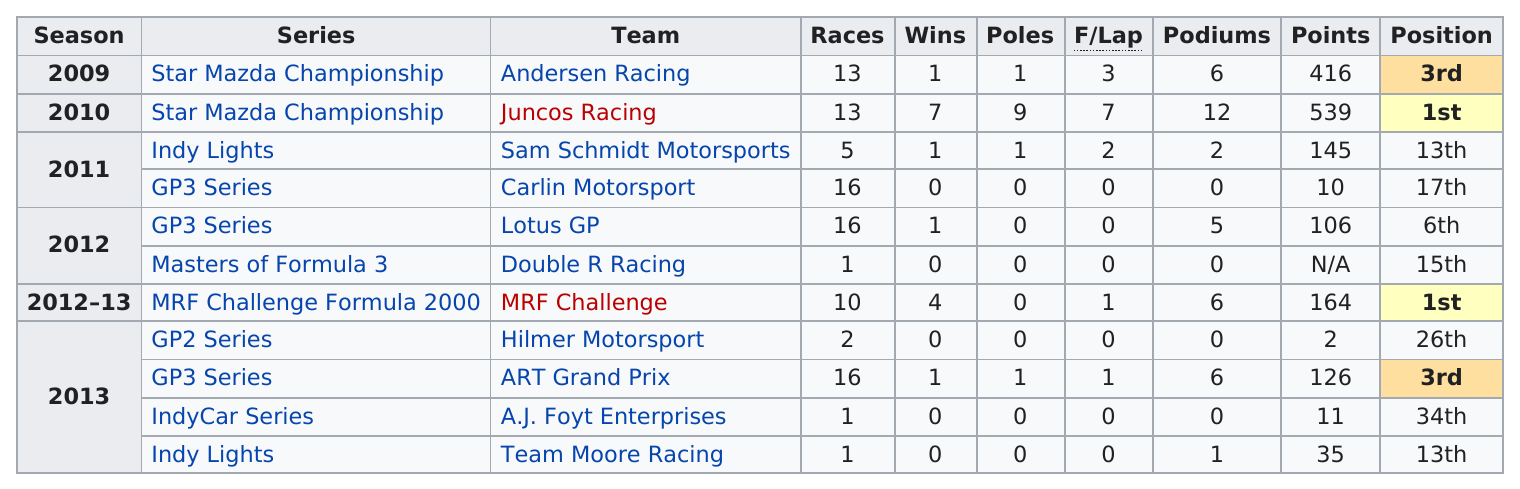Outline some significant characteristics in this image. In the 2010 Star Mazda Championship, the highest number of points was earned. Juncos Racing has the highest amount of points among all teams. Daly won the least number of points in a single season with 2 out of a possible 1000 points. Daly has won a total of 12 poles in his career. There are a total of 7 different series listed. 